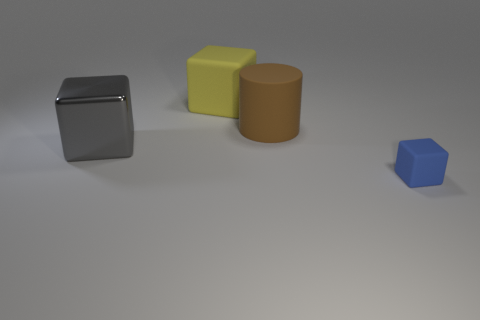What number of other objects are the same material as the yellow thing?
Give a very brief answer. 2. What color is the metallic cube?
Your answer should be compact. Gray. The cylinder that is the same size as the gray object is what color?
Provide a short and direct response. Brown. There is a large thing that is behind the large brown object; does it have the same shape as the tiny blue object that is to the right of the big gray shiny object?
Your answer should be very brief. Yes. What number of other things are there of the same size as the cylinder?
Keep it short and to the point. 2. Is the number of big metal objects in front of the large brown matte object less than the number of objects that are to the left of the tiny rubber cube?
Offer a very short reply. Yes. There is a thing that is both to the left of the brown thing and in front of the large brown cylinder; what is its color?
Offer a terse response. Gray. There is a cylinder; is its size the same as the matte cube that is to the left of the blue rubber block?
Provide a succinct answer. Yes. What shape is the matte thing in front of the metal block?
Give a very brief answer. Cube. Is there anything else that is the same material as the big gray block?
Offer a terse response. No. 